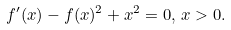Convert formula to latex. <formula><loc_0><loc_0><loc_500><loc_500>f ^ { \prime } ( x ) - f ( x ) ^ { 2 } + x ^ { 2 } = 0 , \, x > 0 .</formula> 